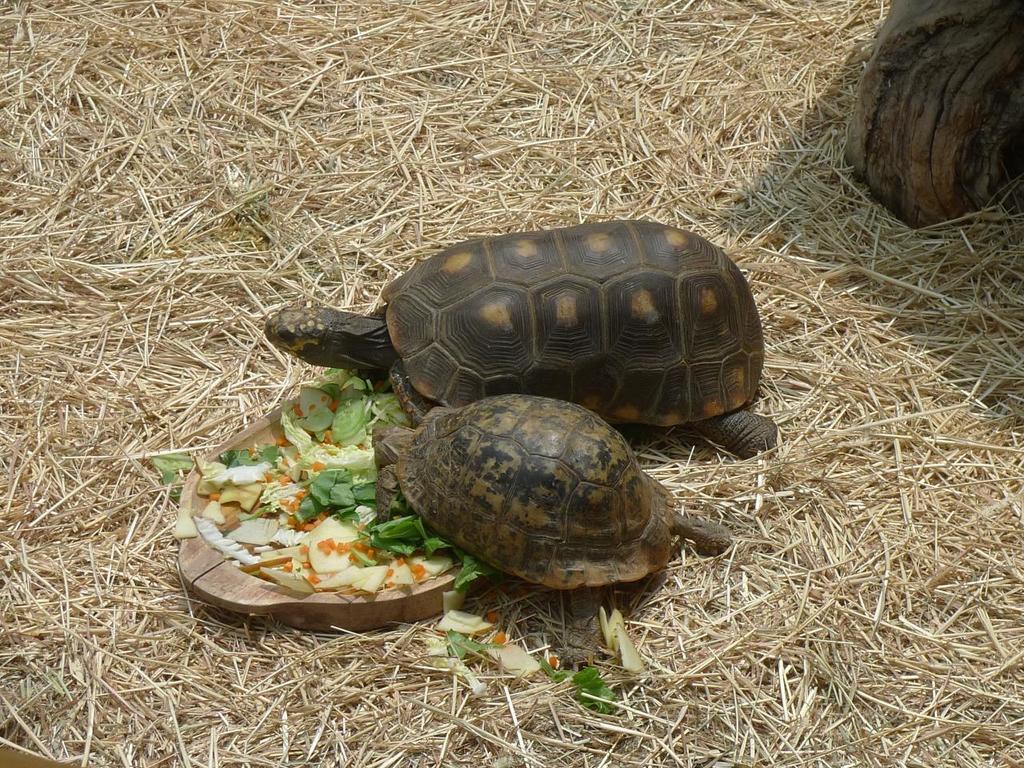In one or two sentences, can you explain what this image depicts? In this image there are two tortoises, there is a wooden bowl, there is food in the bowl, there is a wooden object towards the top of the image, there is dried grass. 